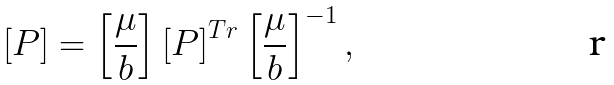Convert formula to latex. <formula><loc_0><loc_0><loc_500><loc_500>\left [ P \right ] = \left [ \frac { \mu } { b } \right ] \left [ P \right ] ^ { T r } \left [ \frac { \mu } { b } \right ] ^ { - 1 } ,</formula> 